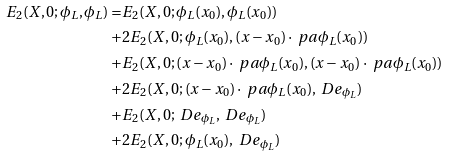Convert formula to latex. <formula><loc_0><loc_0><loc_500><loc_500>E _ { 2 } ( X , 0 ; \phi _ { L } , \phi _ { L } ) = & E _ { 2 } ( X , 0 ; \phi _ { L } ( x _ { 0 } ) , \phi _ { L } ( x _ { 0 } ) ) \\ + & 2 E _ { 2 } ( X , 0 ; \phi _ { L } ( x _ { 0 } ) , ( x - x _ { 0 } ) \cdot \ p a \phi _ { L } ( x _ { 0 } ) ) \\ + & E _ { 2 } ( X , 0 ; ( x - x _ { 0 } ) \cdot \ p a \phi _ { L } ( x _ { 0 } ) , ( x - x _ { 0 } ) \cdot \ p a \phi _ { L } ( x _ { 0 } ) ) \\ + & 2 E _ { 2 } ( X , 0 ; ( x - x _ { 0 } ) \cdot \ p a \phi _ { L } ( x _ { 0 } ) , \ D e _ { \phi _ { L } } ) \\ + & E _ { 2 } ( X , 0 ; \ D e _ { \phi _ { L } } , \ D e _ { \phi _ { L } } ) \\ + & 2 E _ { 2 } ( X , 0 ; \phi _ { L } ( x _ { 0 } ) , \ D e _ { \phi _ { L } } ) \\</formula> 